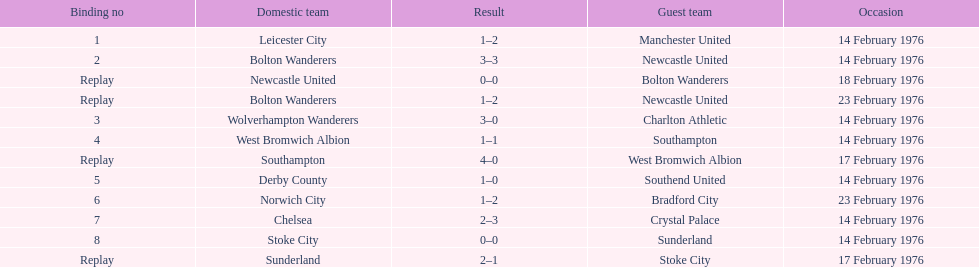Help me parse the entirety of this table. {'header': ['Binding no', 'Domestic team', 'Result', 'Guest team', 'Occasion'], 'rows': [['1', 'Leicester City', '1–2', 'Manchester United', '14 February 1976'], ['2', 'Bolton Wanderers', '3–3', 'Newcastle United', '14 February 1976'], ['Replay', 'Newcastle United', '0–0', 'Bolton Wanderers', '18 February 1976'], ['Replay', 'Bolton Wanderers', '1–2', 'Newcastle United', '23 February 1976'], ['3', 'Wolverhampton Wanderers', '3–0', 'Charlton Athletic', '14 February 1976'], ['4', 'West Bromwich Albion', '1–1', 'Southampton', '14 February 1976'], ['Replay', 'Southampton', '4–0', 'West Bromwich Albion', '17 February 1976'], ['5', 'Derby County', '1–0', 'Southend United', '14 February 1976'], ['6', 'Norwich City', '1–2', 'Bradford City', '23 February 1976'], ['7', 'Chelsea', '2–3', 'Crystal Palace', '14 February 1976'], ['8', 'Stoke City', '0–0', 'Sunderland', '14 February 1976'], ['Replay', 'Sunderland', '2–1', 'Stoke City', '17 February 1976']]} What is the difference between southampton's score and sunderland's score? 2 goals. 